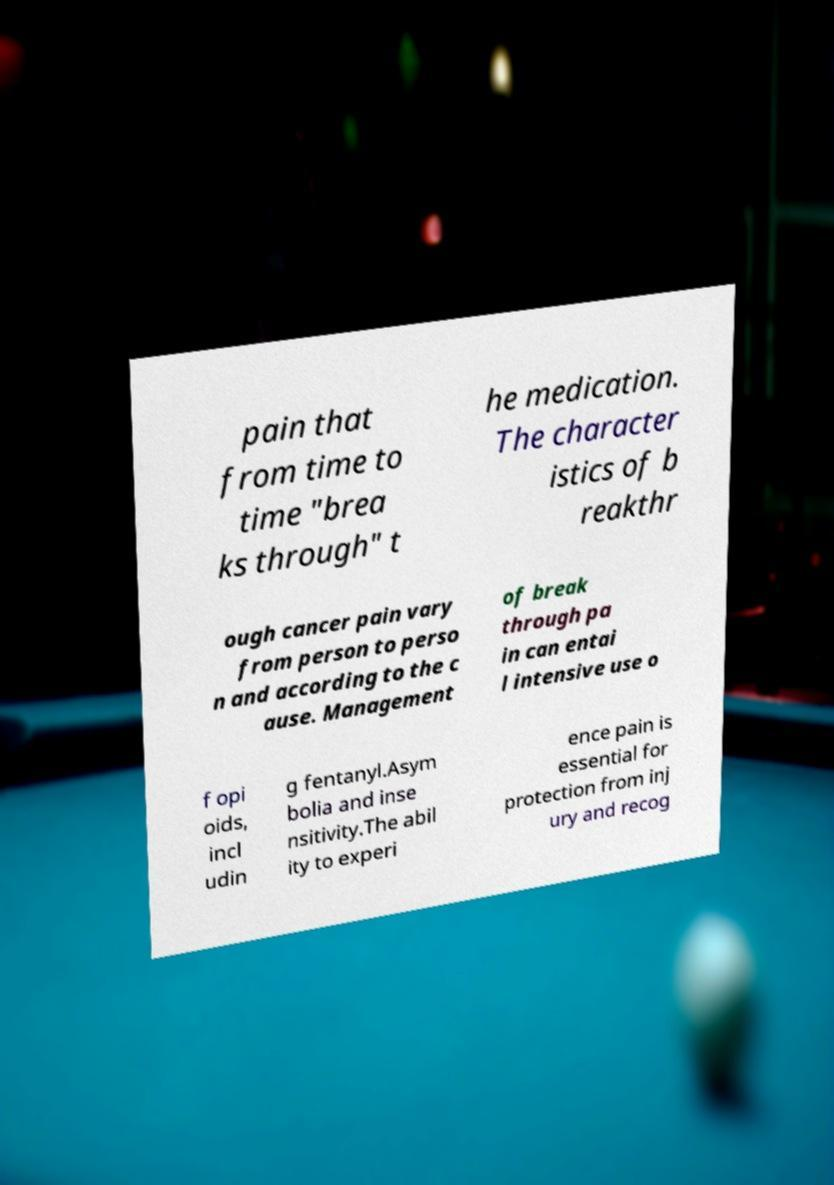Can you accurately transcribe the text from the provided image for me? pain that from time to time "brea ks through" t he medication. The character istics of b reakthr ough cancer pain vary from person to perso n and according to the c ause. Management of break through pa in can entai l intensive use o f opi oids, incl udin g fentanyl.Asym bolia and inse nsitivity.The abil ity to experi ence pain is essential for protection from inj ury and recog 